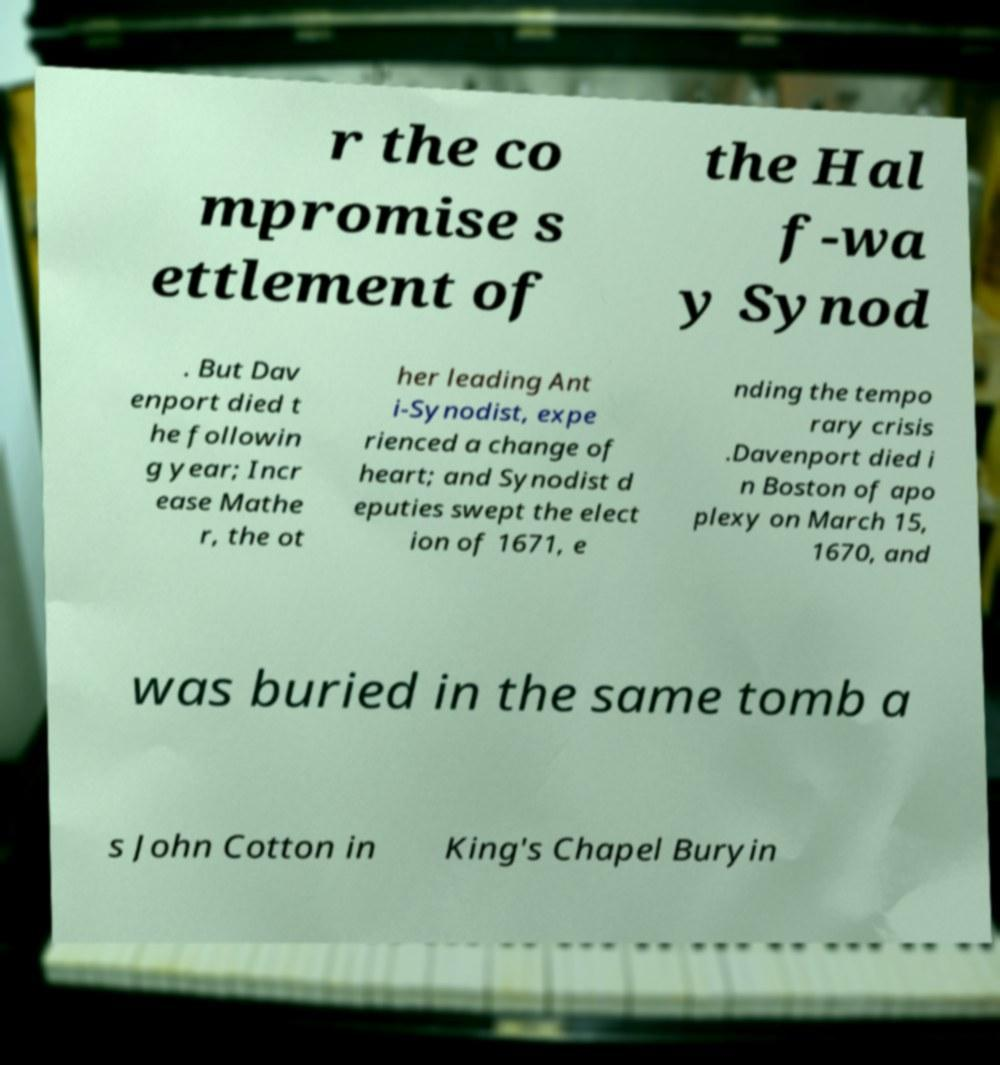Please read and relay the text visible in this image. What does it say? r the co mpromise s ettlement of the Hal f-wa y Synod . But Dav enport died t he followin g year; Incr ease Mathe r, the ot her leading Ant i-Synodist, expe rienced a change of heart; and Synodist d eputies swept the elect ion of 1671, e nding the tempo rary crisis .Davenport died i n Boston of apo plexy on March 15, 1670, and was buried in the same tomb a s John Cotton in King's Chapel Buryin 